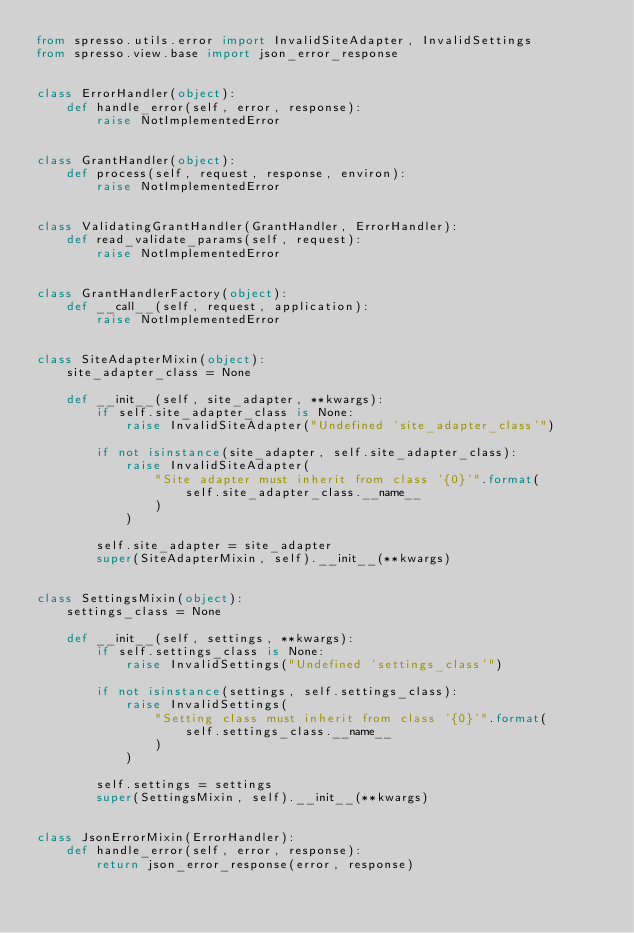<code> <loc_0><loc_0><loc_500><loc_500><_Python_>from spresso.utils.error import InvalidSiteAdapter, InvalidSettings
from spresso.view.base import json_error_response


class ErrorHandler(object):
    def handle_error(self, error, response):
        raise NotImplementedError


class GrantHandler(object):
    def process(self, request, response, environ):
        raise NotImplementedError


class ValidatingGrantHandler(GrantHandler, ErrorHandler):
    def read_validate_params(self, request):
        raise NotImplementedError


class GrantHandlerFactory(object):
    def __call__(self, request, application):
        raise NotImplementedError


class SiteAdapterMixin(object):
    site_adapter_class = None

    def __init__(self, site_adapter, **kwargs):
        if self.site_adapter_class is None:
            raise InvalidSiteAdapter("Undefined 'site_adapter_class'")

        if not isinstance(site_adapter, self.site_adapter_class):
            raise InvalidSiteAdapter(
                "Site adapter must inherit from class '{0}'".format(
                    self.site_adapter_class.__name__
                )
            )

        self.site_adapter = site_adapter
        super(SiteAdapterMixin, self).__init__(**kwargs)


class SettingsMixin(object):
    settings_class = None

    def __init__(self, settings, **kwargs):
        if self.settings_class is None:
            raise InvalidSettings("Undefined 'settings_class'")

        if not isinstance(settings, self.settings_class):
            raise InvalidSettings(
                "Setting class must inherit from class '{0}'".format(
                    self.settings_class.__name__
                )
            )

        self.settings = settings
        super(SettingsMixin, self).__init__(**kwargs)


class JsonErrorMixin(ErrorHandler):
    def handle_error(self, error, response):
        return json_error_response(error, response)
</code> 